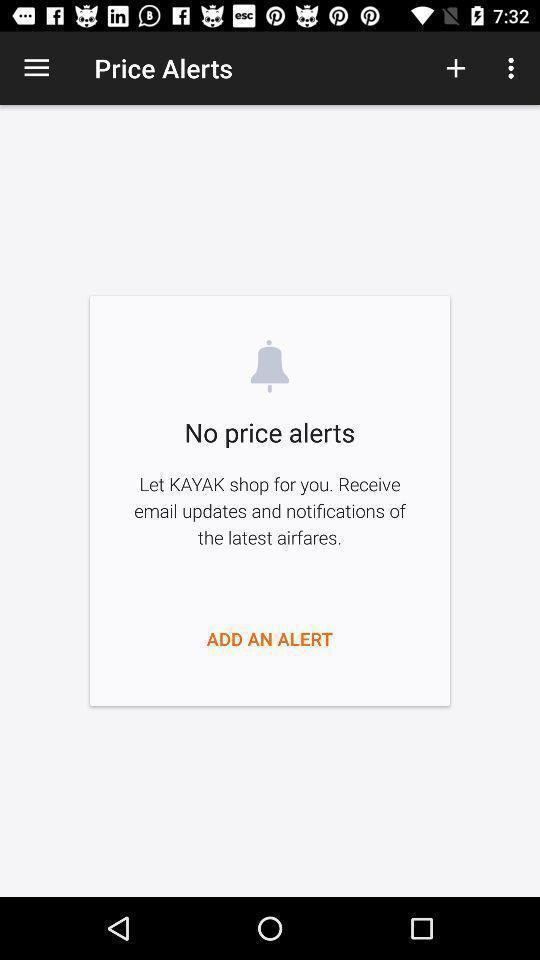Please provide a description for this image. Screen displaying price alerts page of a travel app. 